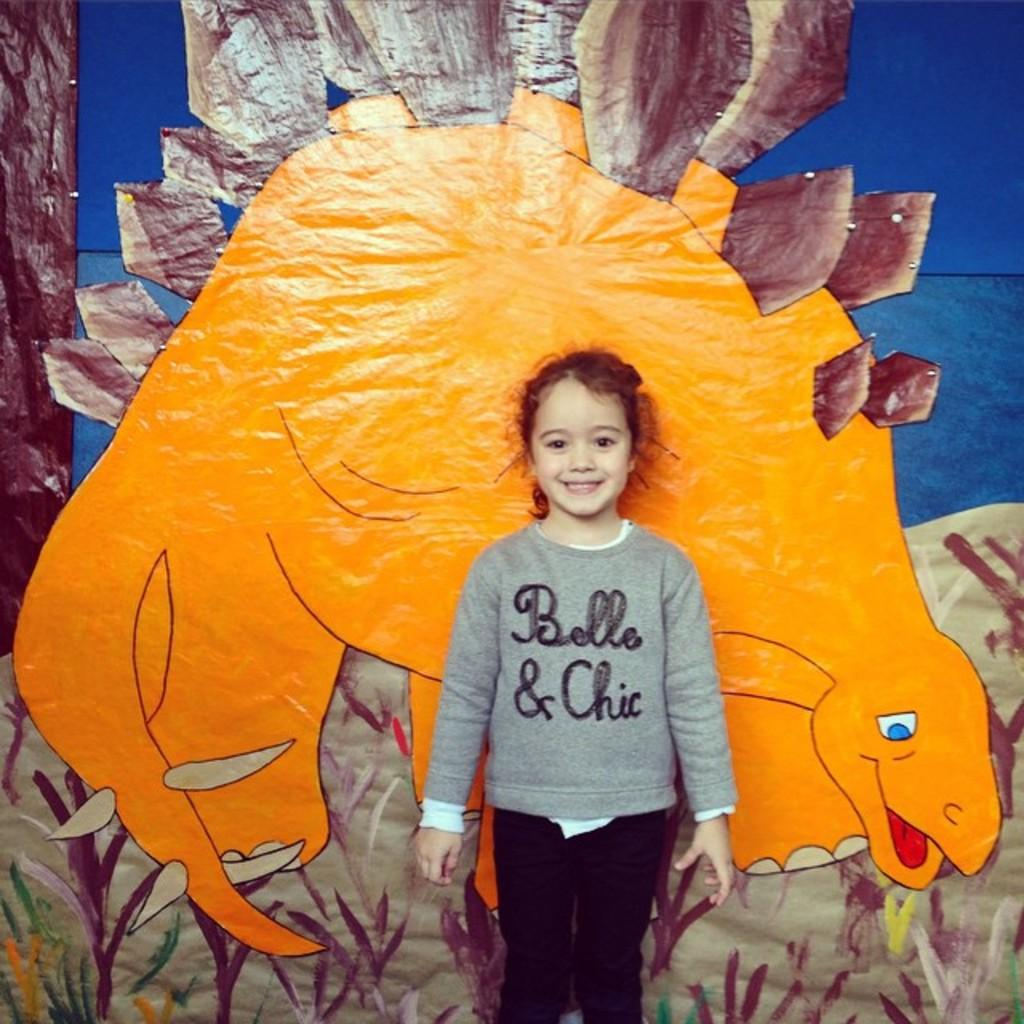What is the girl in the image doing? The girl is standing and drawing in the image. What is included in the girl's drawing? The drawing includes an animal and plants. Can you tell me how many ants are crawling on the girl's drawing in the image? There is no reference to ants in the image, so it is not possible to determine how many ants might be crawling on the girl's drawing. 